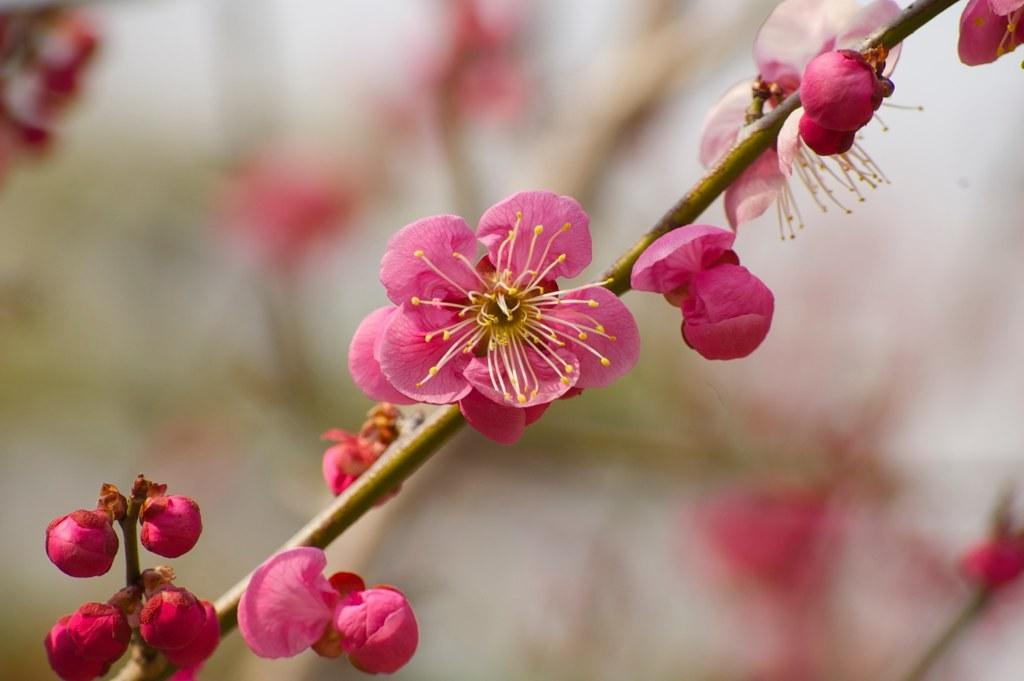What type of plant life is visible in the image? There are flowers, buds, and stems visible in the image. Can you describe the stage of growth for the flowers in the image? The flowers in the image have buds, which suggests they are in the process of blooming. What is the condition of the background in the image? The background of the image is blurry. What type of grain can be seen growing in the image? There is no grain present in the image; it features flowers, buds, and stems. How many trees are visible in the image? There are no trees visible in the image; it features flowers, buds, and stems. 